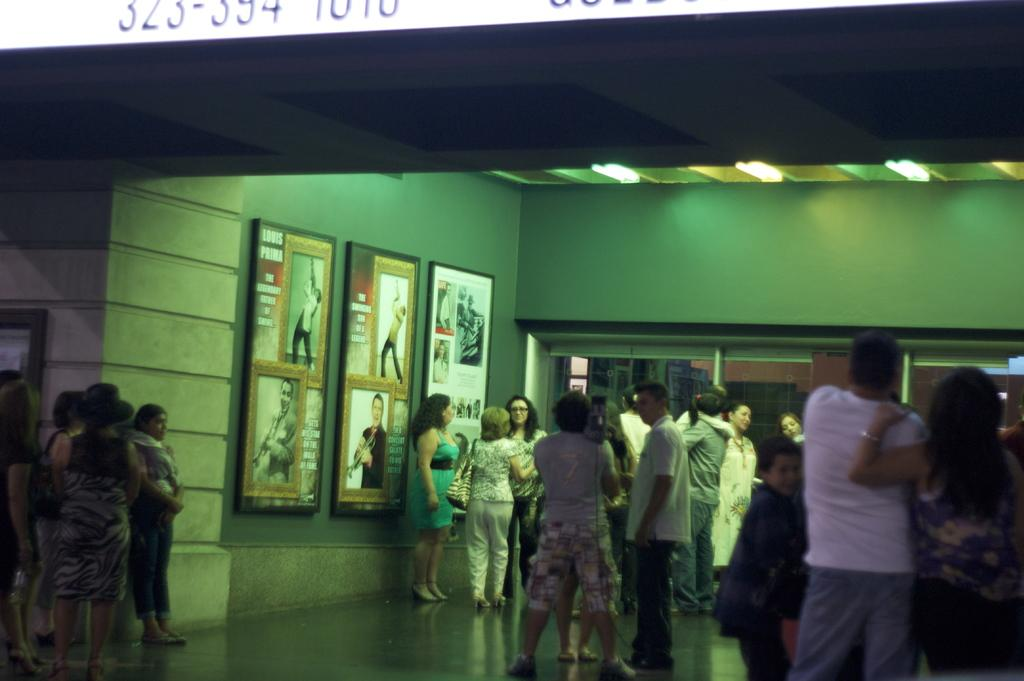Who or what is present in the image? There are people in the image. What is the surface beneath the people? There is a floor visible in the image. What is attached to the wall in the image? There are boards on the wall in the image. What is providing illumination in the image? There are lights in the image. What can be seen at the top of the image? There are numbers at the top of the image. What type of pleasure can be seen enjoying a swim in the lake in the image? There is no lake or pleasure present in the image; it features people, a floor, boards on the wall, lights, and numbers at the top. What is the fifth element in the image? The provided facts do not mention a fifth element in the image. 